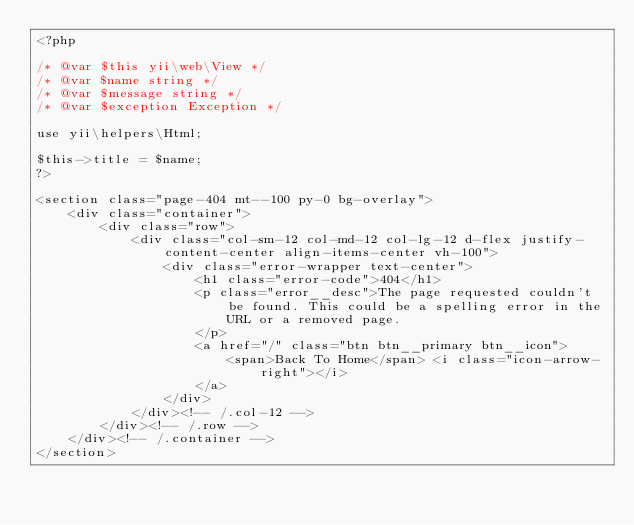Convert code to text. <code><loc_0><loc_0><loc_500><loc_500><_PHP_><?php

/* @var $this yii\web\View */
/* @var $name string */
/* @var $message string */
/* @var $exception Exception */

use yii\helpers\Html;

$this->title = $name;
?>

<section class="page-404 mt--100 py-0 bg-overlay">
    <div class="container">
        <div class="row">
            <div class="col-sm-12 col-md-12 col-lg-12 d-flex justify-content-center align-items-center vh-100">
                <div class="error-wrapper text-center">
                    <h1 class="error-code">404</h1>
                    <p class="error__desc">The page requested couldn't be found. This could be a spelling error in the
                        URL or a removed page.
                    </p>
                    <a href="/" class="btn btn__primary btn__icon">
                        <span>Back To Home</span> <i class="icon-arrow-right"></i>
                    </a>
                </div>
            </div><!-- /.col-12 -->
        </div><!-- /.row -->
    </div><!-- /.container -->
</section>
</code> 